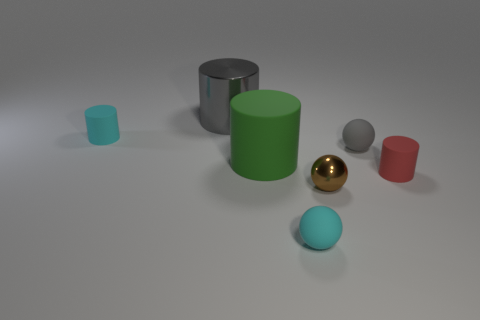Is there anything else that is the same size as the gray metallic cylinder?
Ensure brevity in your answer.  Yes. The big object that is in front of the metallic thing that is left of the large matte cylinder is made of what material?
Provide a succinct answer. Rubber. Are there any large green objects that have the same shape as the red rubber object?
Your response must be concise. Yes. The gray matte thing is what shape?
Keep it short and to the point. Sphere. What is the material of the object behind the cyan matte thing left of the large cylinder behind the green thing?
Provide a succinct answer. Metal. Is the number of tiny gray spheres in front of the tiny brown shiny sphere greater than the number of large cylinders?
Provide a succinct answer. No. There is a cyan ball that is the same size as the cyan cylinder; what material is it?
Keep it short and to the point. Rubber. Is there a rubber cube of the same size as the cyan ball?
Make the answer very short. No. What is the size of the cyan rubber object that is right of the big rubber object?
Offer a terse response. Small. How big is the gray cylinder?
Offer a terse response. Large. 